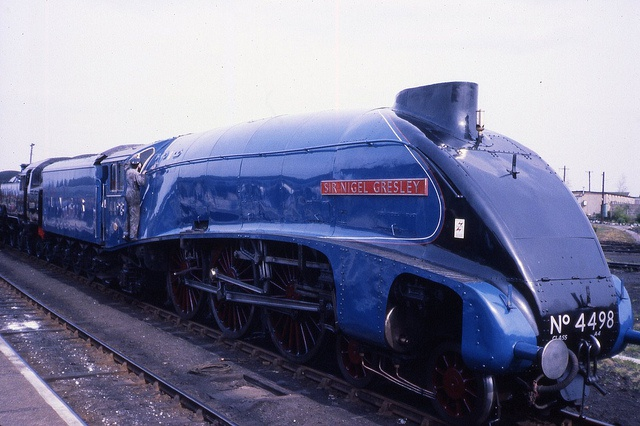Describe the objects in this image and their specific colors. I can see train in lavender, black, navy, gray, and darkgray tones and people in lavender, gray, purple, navy, and black tones in this image. 